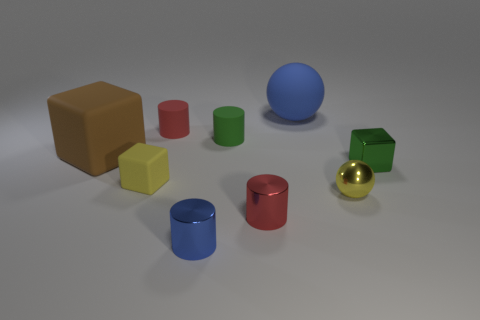There is a tiny object that is the same color as the tiny shiny cube; what is its material?
Ensure brevity in your answer.  Rubber. There is another shiny thing that is the same shape as the small blue thing; what is its color?
Ensure brevity in your answer.  Red. Are there any tiny blue metallic things that are behind the red object that is in front of the tiny red rubber thing behind the green rubber cylinder?
Make the answer very short. No. Do the brown thing and the red metallic thing have the same shape?
Offer a very short reply. No. Is the number of matte balls right of the blue rubber ball less than the number of brown cubes?
Your response must be concise. Yes. What color is the ball that is behind the small yellow cube that is in front of the block right of the blue rubber ball?
Your response must be concise. Blue. How many metallic things are either green cylinders or blue objects?
Provide a short and direct response. 1. Do the green metal thing and the brown cube have the same size?
Keep it short and to the point. No. Are there fewer shiny cylinders that are behind the yellow metal ball than big matte objects that are in front of the green metallic object?
Offer a very short reply. No. How big is the green cylinder?
Keep it short and to the point. Small. 